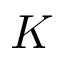Convert formula to latex. <formula><loc_0><loc_0><loc_500><loc_500>K</formula> 